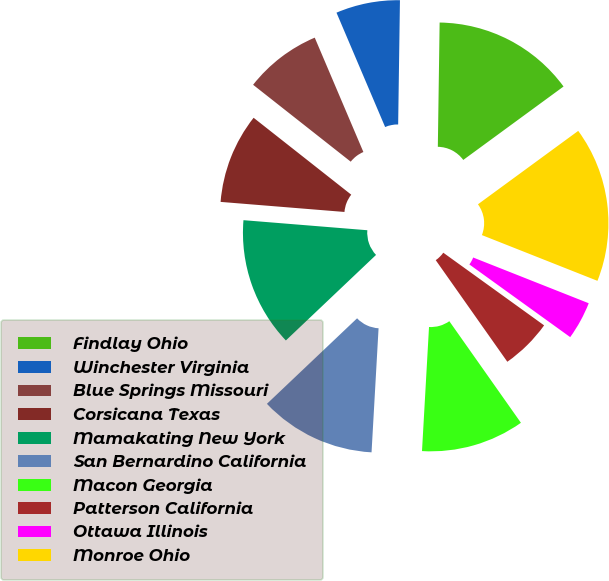<chart> <loc_0><loc_0><loc_500><loc_500><pie_chart><fcel>Findlay Ohio<fcel>Winchester Virginia<fcel>Blue Springs Missouri<fcel>Corsicana Texas<fcel>Mamakating New York<fcel>San Bernardino California<fcel>Macon Georgia<fcel>Patterson California<fcel>Ottawa Illinois<fcel>Monroe Ohio<nl><fcel>14.71%<fcel>6.63%<fcel>7.98%<fcel>9.33%<fcel>13.37%<fcel>12.02%<fcel>10.67%<fcel>5.29%<fcel>3.94%<fcel>16.06%<nl></chart> 